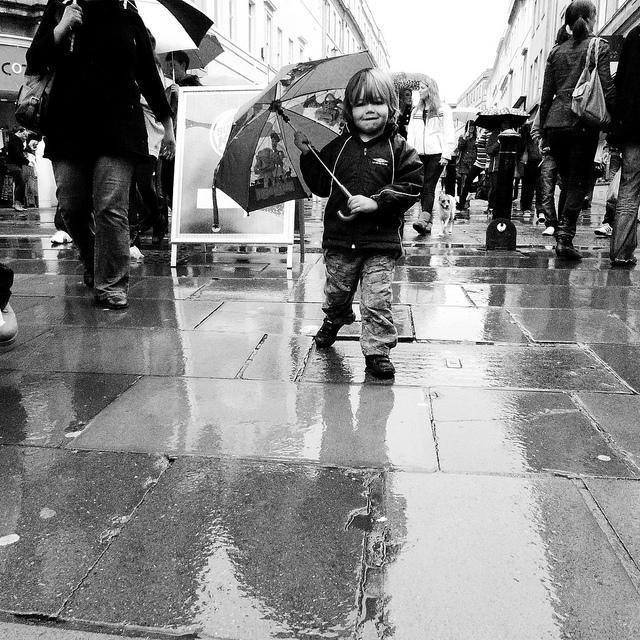How many people can you see?
Give a very brief answer. 6. How many umbrellas can be seen?
Give a very brief answer. 2. 